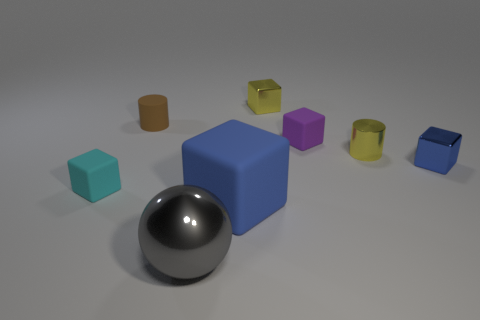Are there any small blue metallic things that have the same shape as the cyan matte object?
Your answer should be compact. Yes. There is a blue shiny thing that is the same size as the brown matte thing; what is its shape?
Give a very brief answer. Cube. Does the big metallic ball have the same color as the small cube that is to the left of the large blue block?
Provide a short and direct response. No. What number of tiny purple rubber blocks are in front of the matte block that is to the left of the large blue cube?
Make the answer very short. 0. What is the size of the matte object that is in front of the brown cylinder and on the left side of the gray shiny thing?
Provide a succinct answer. Small. Are there any blue rubber blocks of the same size as the cyan block?
Your answer should be compact. No. Is the number of large shiny spheres behind the small blue metal thing greater than the number of tiny brown matte objects left of the rubber cylinder?
Provide a short and direct response. No. Is the large gray sphere made of the same material as the tiny blue thing that is on the right side of the large rubber thing?
Provide a succinct answer. Yes. How many big rubber objects are in front of the matte cylinder that is left of the tiny cylinder on the right side of the tiny yellow metallic block?
Offer a terse response. 1. There is a small brown thing; is it the same shape as the yellow metal object in front of the tiny brown matte thing?
Give a very brief answer. Yes. 